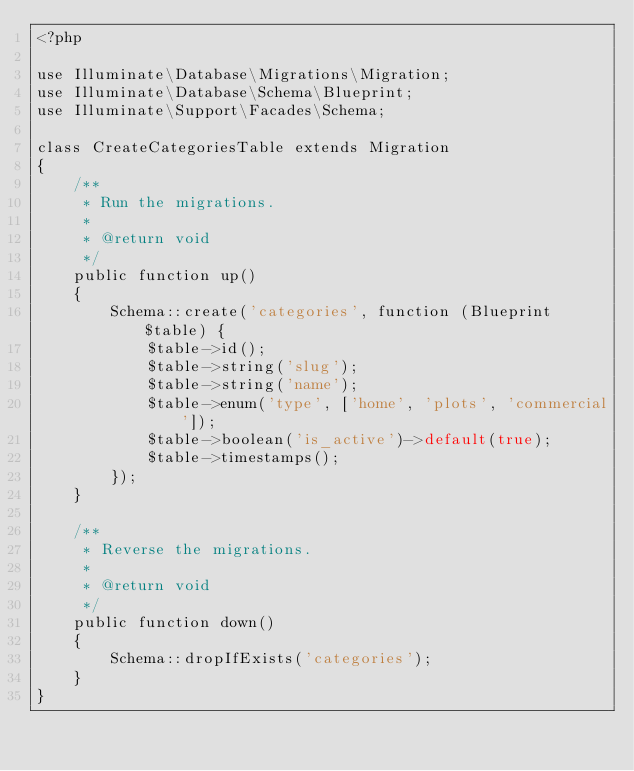Convert code to text. <code><loc_0><loc_0><loc_500><loc_500><_PHP_><?php

use Illuminate\Database\Migrations\Migration;
use Illuminate\Database\Schema\Blueprint;
use Illuminate\Support\Facades\Schema;

class CreateCategoriesTable extends Migration
{
    /**
     * Run the migrations.
     *
     * @return void
     */
    public function up()
    {
        Schema::create('categories', function (Blueprint $table) {
            $table->id();
            $table->string('slug');
            $table->string('name');
            $table->enum('type', ['home', 'plots', 'commercial']);
            $table->boolean('is_active')->default(true);
            $table->timestamps();
        });
    }

    /**
     * Reverse the migrations.
     *
     * @return void
     */
    public function down()
    {
        Schema::dropIfExists('categories');
    }
}
</code> 